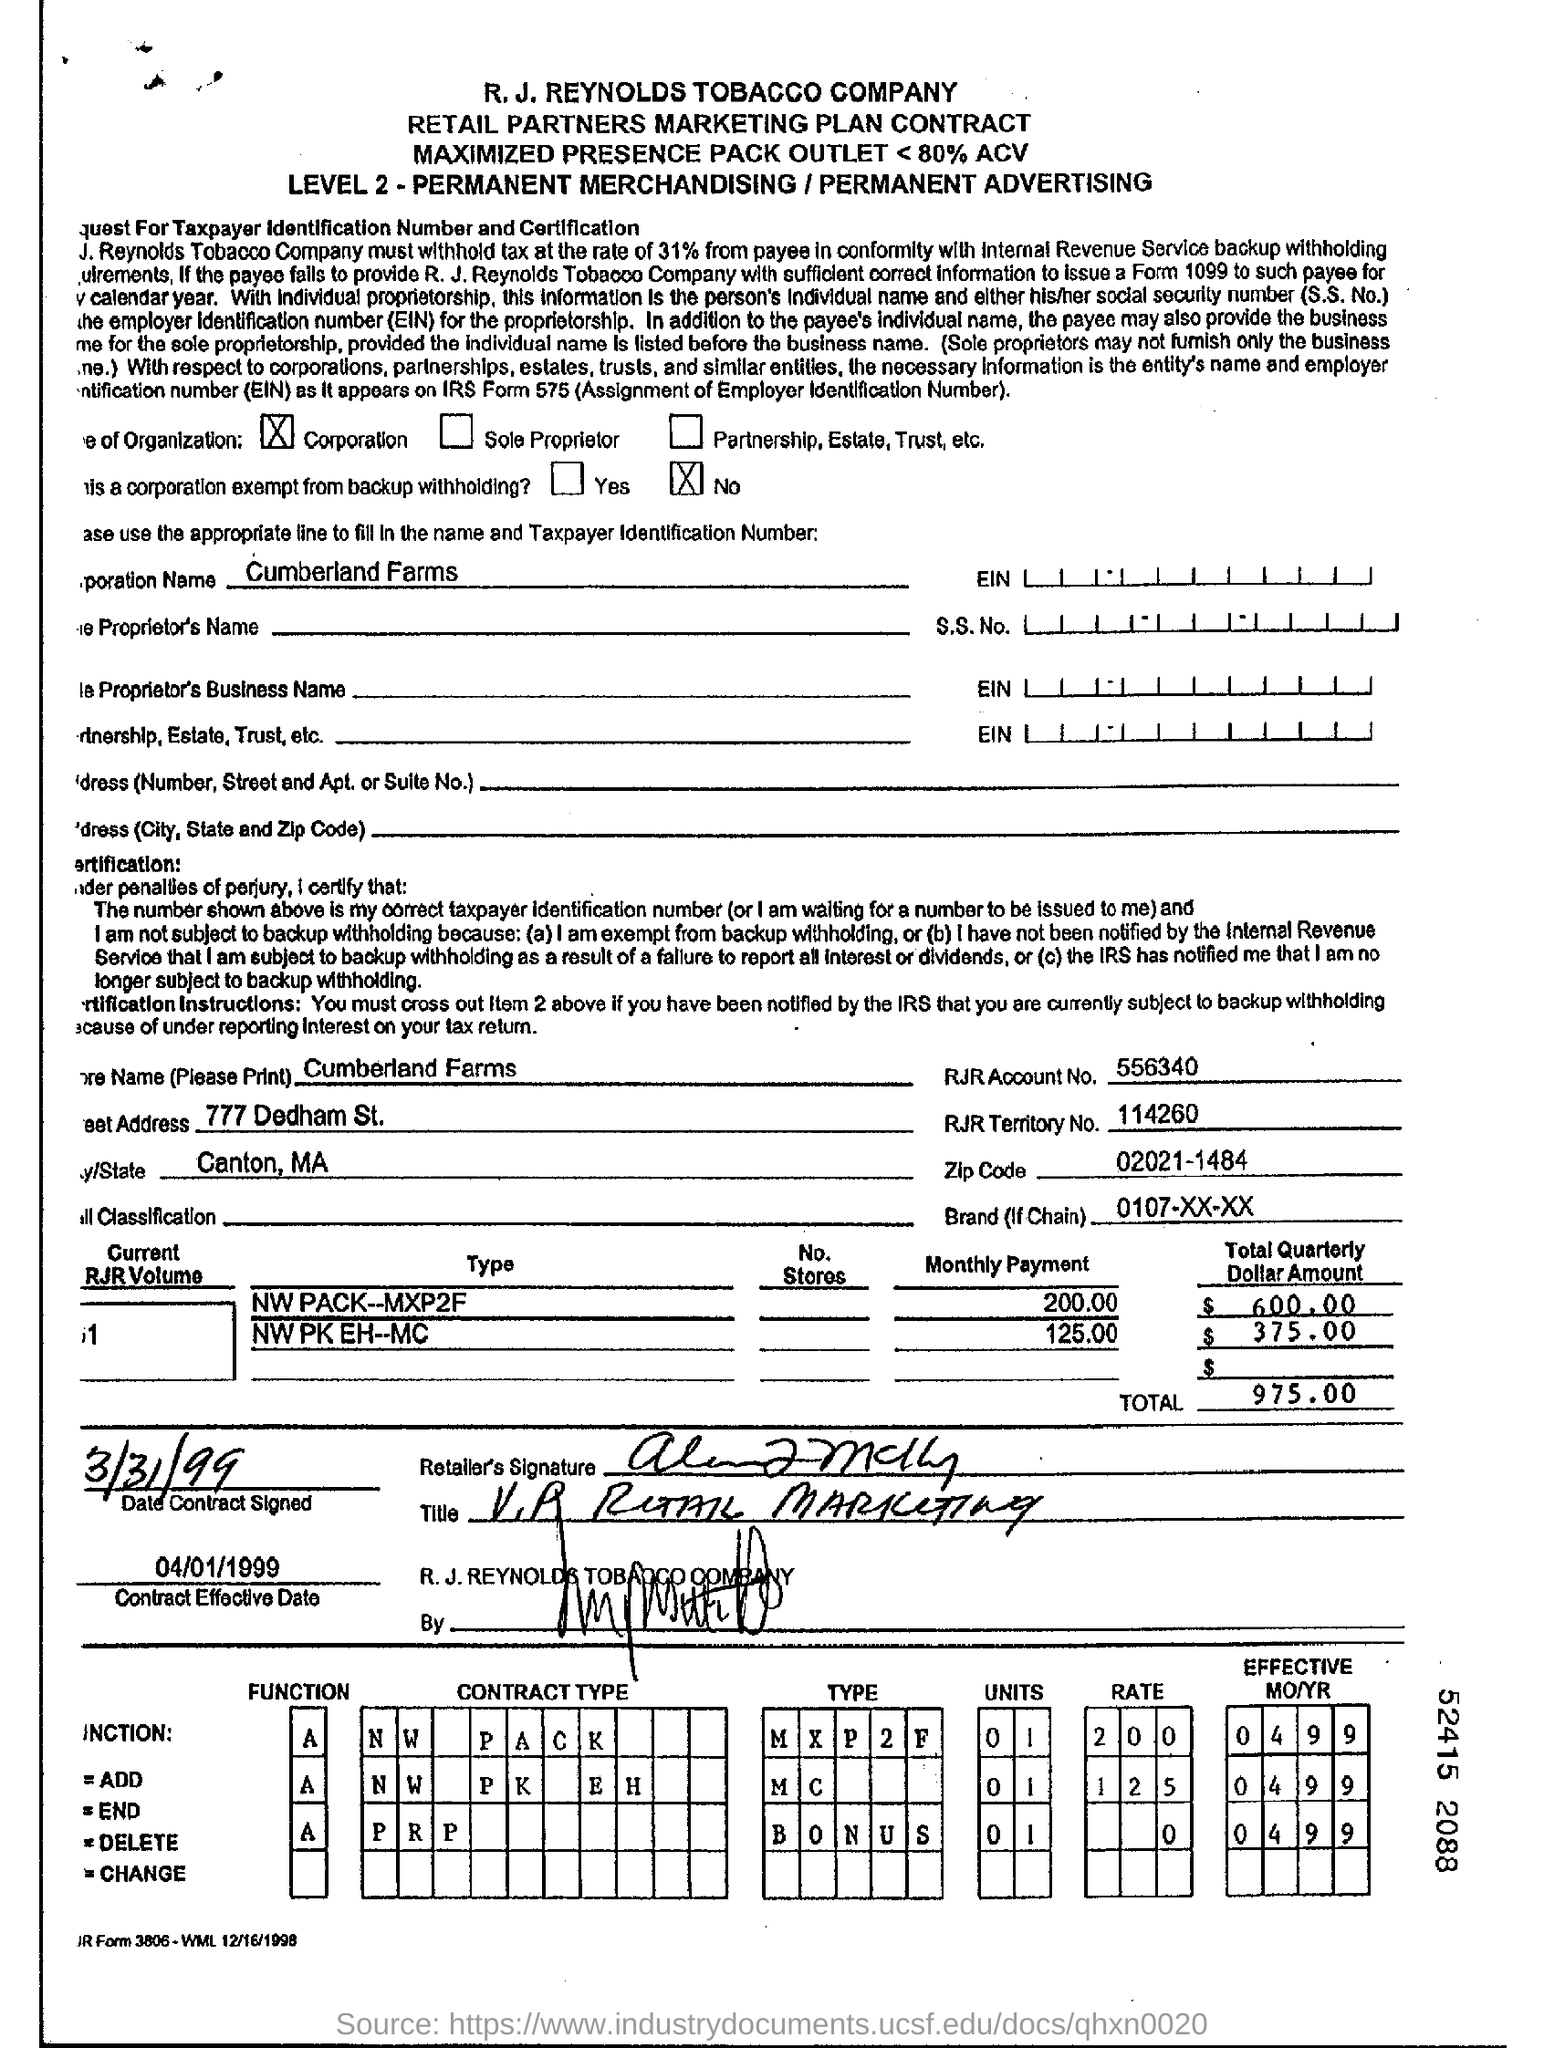What is the RJR Account No.?
Give a very brief answer. 556340. What is the RJR Territory No.?
Your answer should be compact. 114260. What is the Zip code?
Provide a succinct answer. 02021-1484. What is the Total quarterly dollar amount for Type "NW PACK-MXP2F"?
Make the answer very short. $600.00. What is the Total quarterly dollar amount for Type "NW PK EH--MC"?
Keep it short and to the point. $375.00. What is the Total?
Provide a short and direct response. 975.00. What is the date when contract was signed?
Offer a terse response. 3/31/99. 